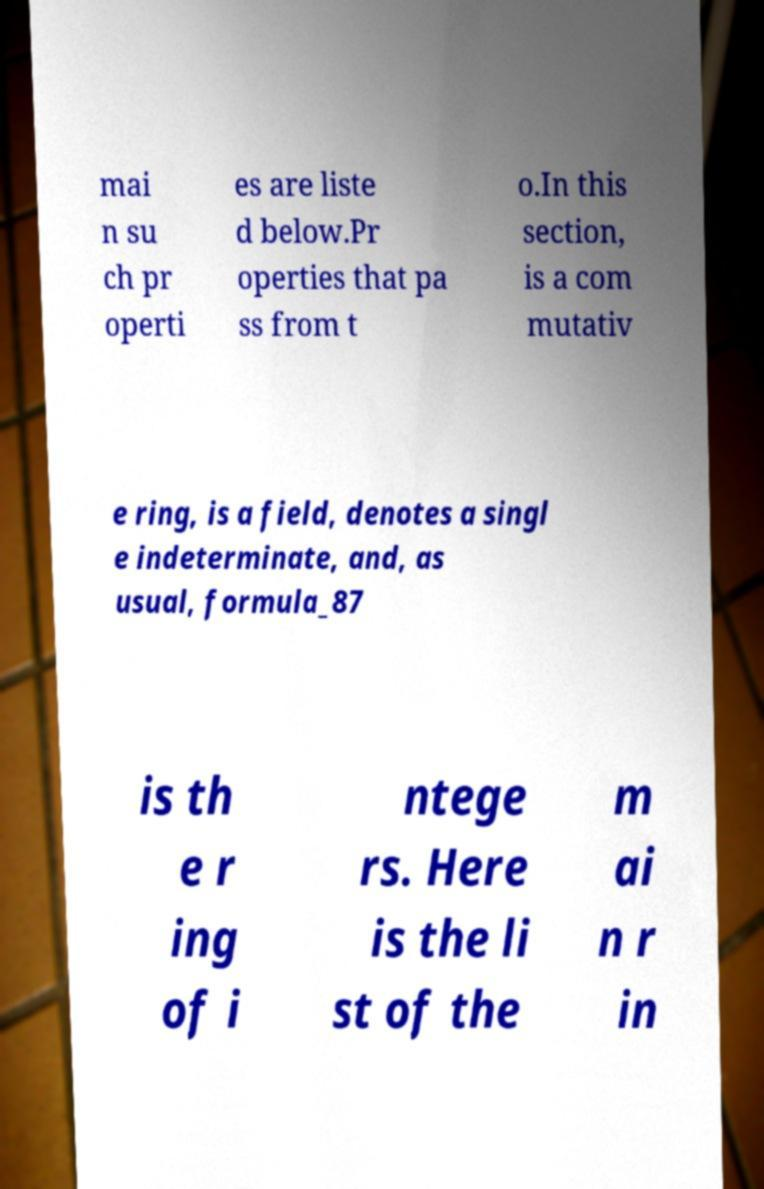What messages or text are displayed in this image? I need them in a readable, typed format. mai n su ch pr operti es are liste d below.Pr operties that pa ss from t o.In this section, is a com mutativ e ring, is a field, denotes a singl e indeterminate, and, as usual, formula_87 is th e r ing of i ntege rs. Here is the li st of the m ai n r in 